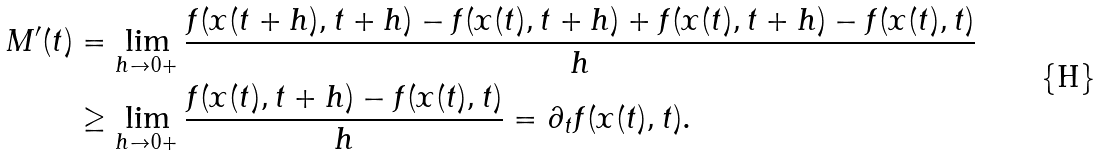<formula> <loc_0><loc_0><loc_500><loc_500>M ^ { \prime } ( t ) & = \lim _ { h \to 0 + } \frac { f ( x ( t + h ) , t + h ) - f ( x ( t ) , t + h ) + f ( x ( t ) , t + h ) - f ( x ( t ) , t ) } { h } \\ & \geq \lim _ { h \to 0 + } \frac { f ( x ( t ) , t + h ) - f ( x ( t ) , t ) } { h } = \partial _ { t } f ( x ( t ) , t ) .</formula> 